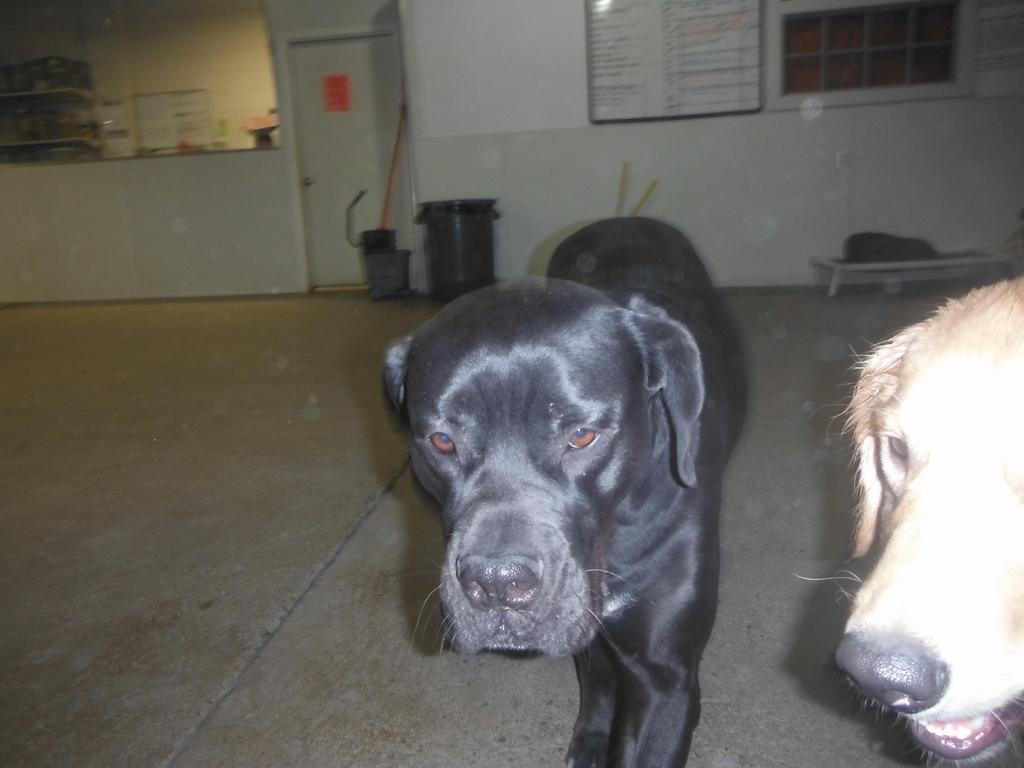How many dogs are in the image? There are two dogs in the image. What can be seen in the background of the image? There is a wall and a door in the background of the image. What is written on the board on the wall? The provided facts do not specify what is written on the board. What is used for waste disposal in the image? There is a dustbin in the image. What other items can be seen in the image besides the dogs and the dustbin? There are other items visible in the image, but the specifics are not mentioned in the provided facts. What type of smoke is coming out of the jar in the image? There is no jar or smoke present in the image. What is the man doing in the image? There is no man present in the image. 